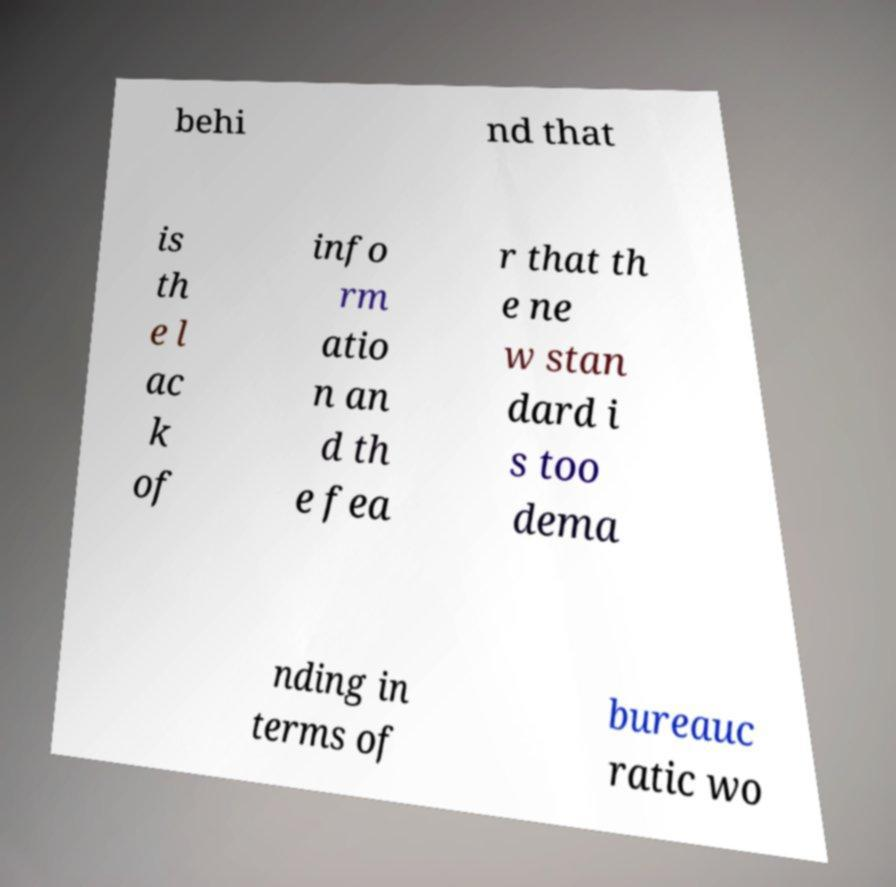For documentation purposes, I need the text within this image transcribed. Could you provide that? behi nd that is th e l ac k of info rm atio n an d th e fea r that th e ne w stan dard i s too dema nding in terms of bureauc ratic wo 